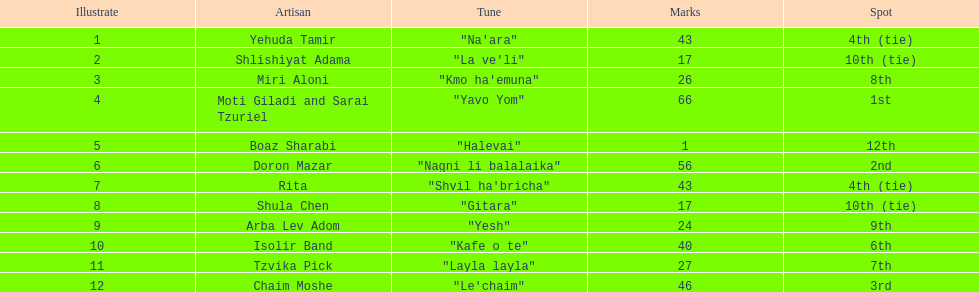Which artist had almost no points? Boaz Sharabi. 